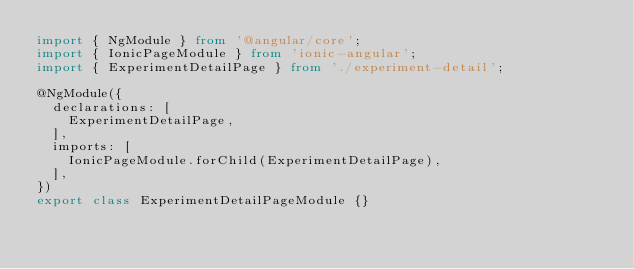Convert code to text. <code><loc_0><loc_0><loc_500><loc_500><_TypeScript_>import { NgModule } from '@angular/core';
import { IonicPageModule } from 'ionic-angular';
import { ExperimentDetailPage } from './experiment-detail';

@NgModule({
  declarations: [
    ExperimentDetailPage,
  ],
  imports: [
    IonicPageModule.forChild(ExperimentDetailPage),
  ],
})
export class ExperimentDetailPageModule {}
</code> 